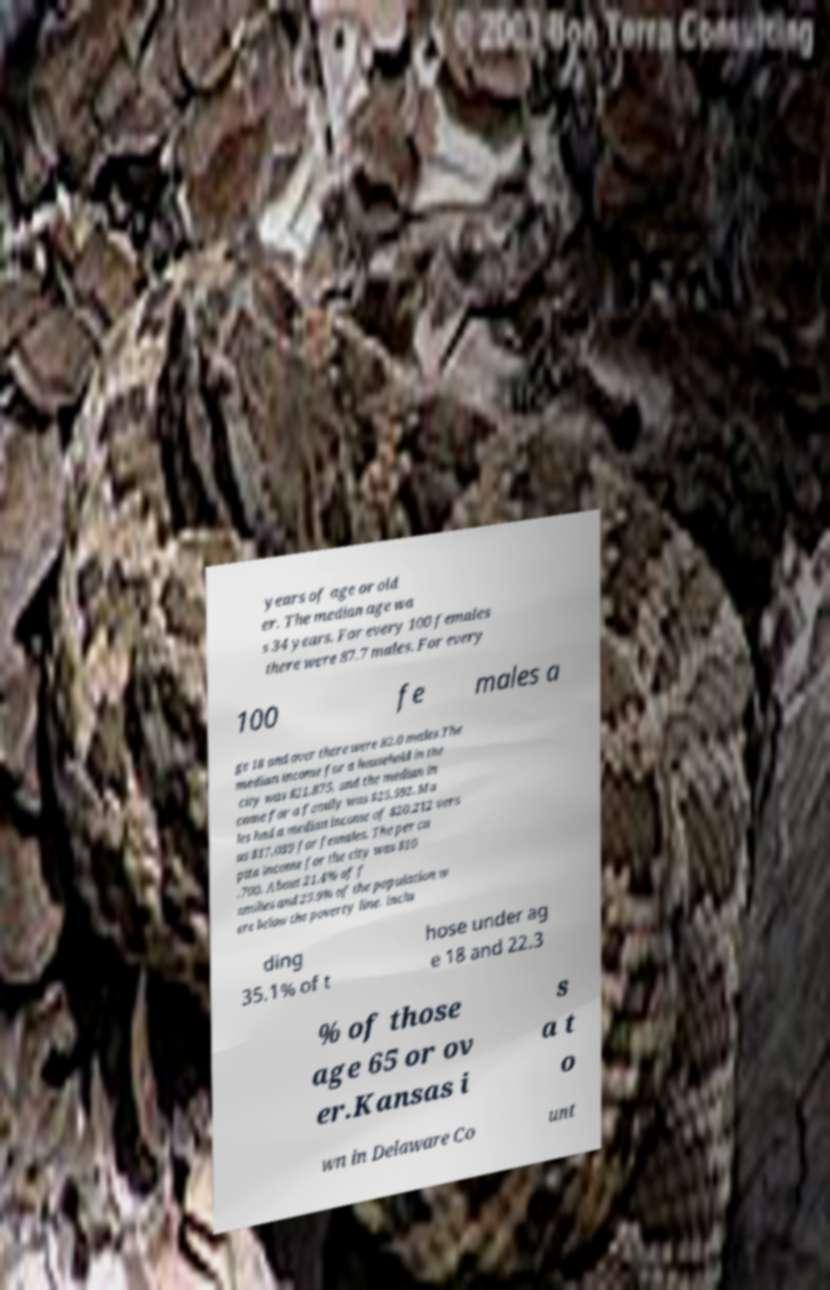Can you accurately transcribe the text from the provided image for me? years of age or old er. The median age wa s 34 years. For every 100 females there were 87.7 males. For every 100 fe males a ge 18 and over there were 82.0 males.The median income for a household in the city was $21,875, and the median in come for a family was $25,592. Ma les had a median income of $20,212 vers us $17,039 for females. The per ca pita income for the city was $10 ,700. About 21.4% of f amilies and 25.9% of the population w ere below the poverty line, inclu ding 35.1% of t hose under ag e 18 and 22.3 % of those age 65 or ov er.Kansas i s a t o wn in Delaware Co unt 